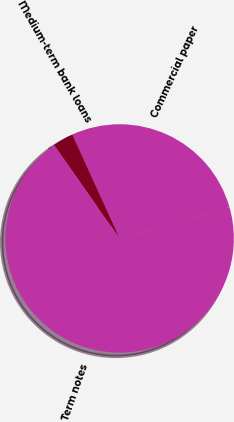<chart> <loc_0><loc_0><loc_500><loc_500><pie_chart><fcel>Commercial paper<fcel>Medium-term bank loans<fcel>Term notes<nl><fcel>27.4%<fcel>2.93%<fcel>69.68%<nl></chart> 